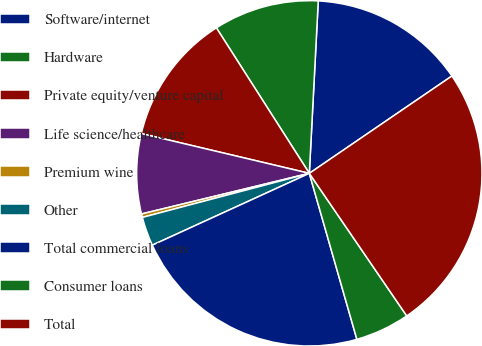Convert chart to OTSL. <chart><loc_0><loc_0><loc_500><loc_500><pie_chart><fcel>Software/internet<fcel>Hardware<fcel>Private equity/venture capital<fcel>Life science/healthcare<fcel>Premium wine<fcel>Other<fcel>Total commercial loans<fcel>Consumer loans<fcel>Total<nl><fcel>14.64%<fcel>9.87%<fcel>12.25%<fcel>7.48%<fcel>0.33%<fcel>2.72%<fcel>22.61%<fcel>5.1%<fcel>24.99%<nl></chart> 